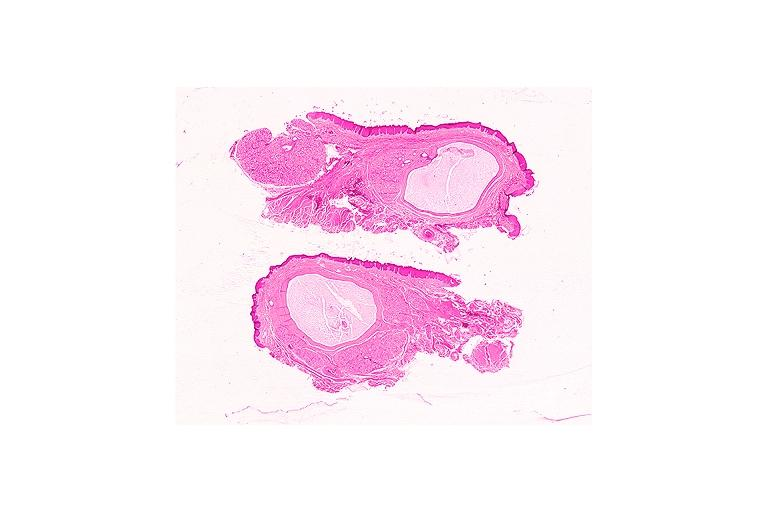what does this image show?
Answer the question using a single word or phrase. Mucocele 